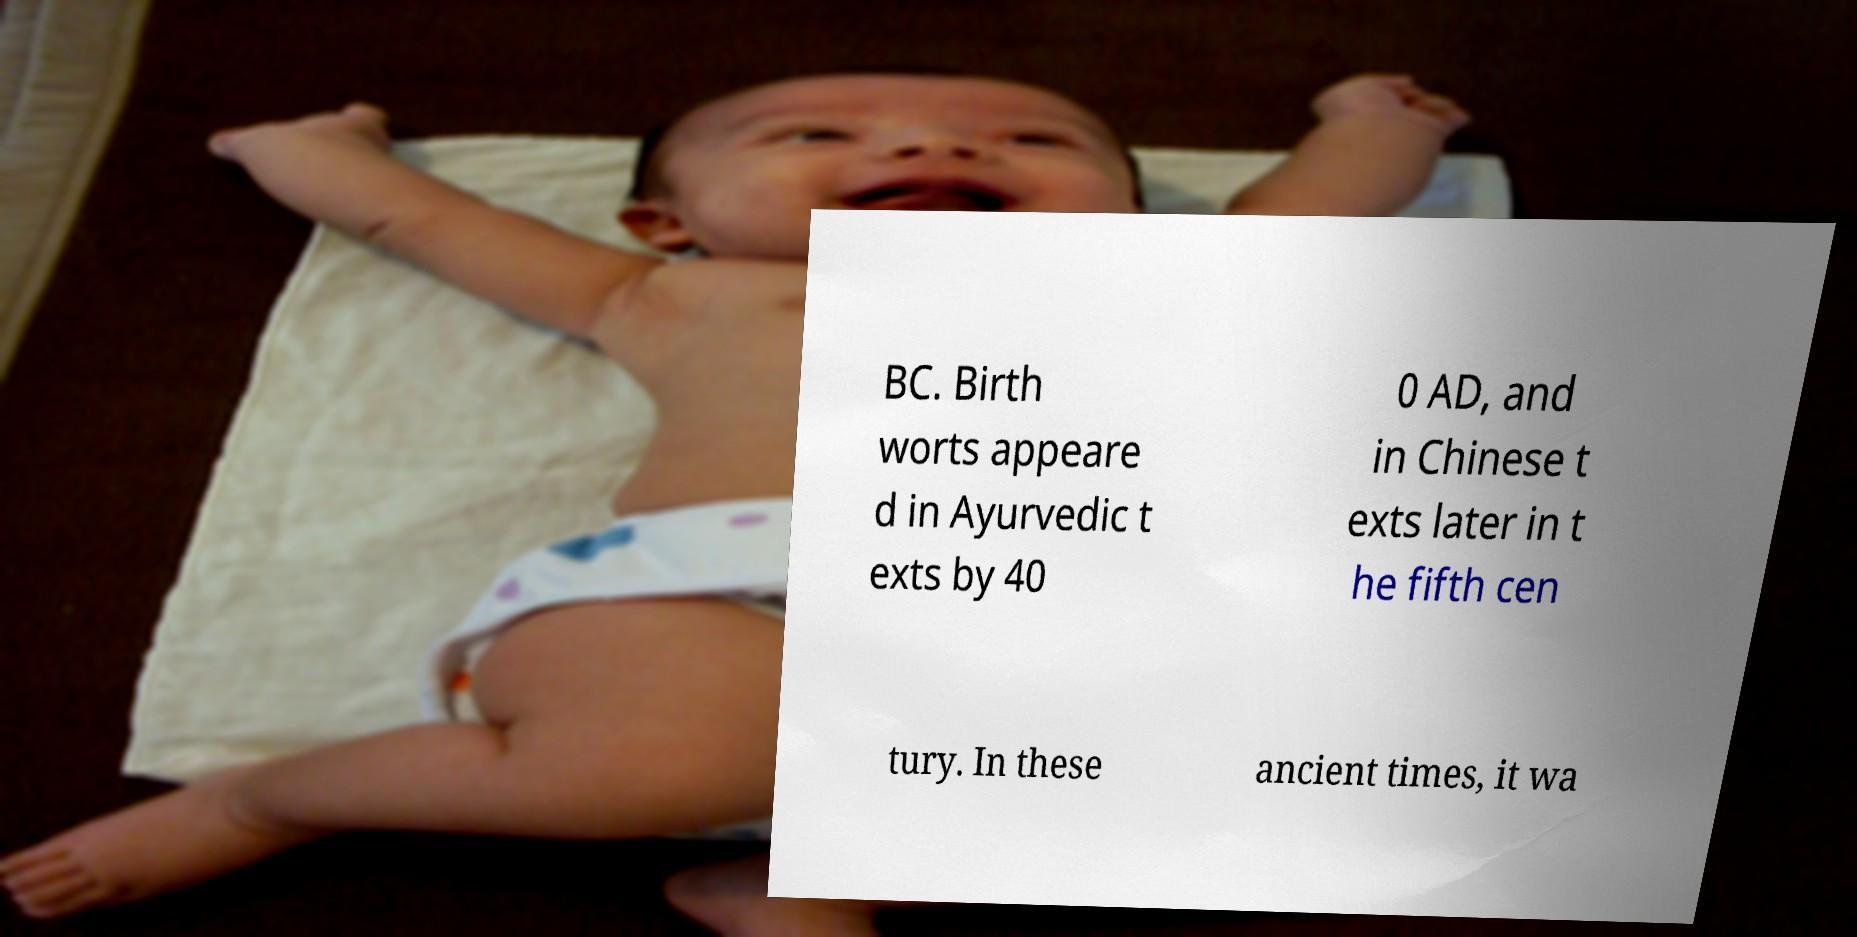Could you extract and type out the text from this image? BC. Birth worts appeare d in Ayurvedic t exts by 40 0 AD, and in Chinese t exts later in t he fifth cen tury. In these ancient times, it wa 